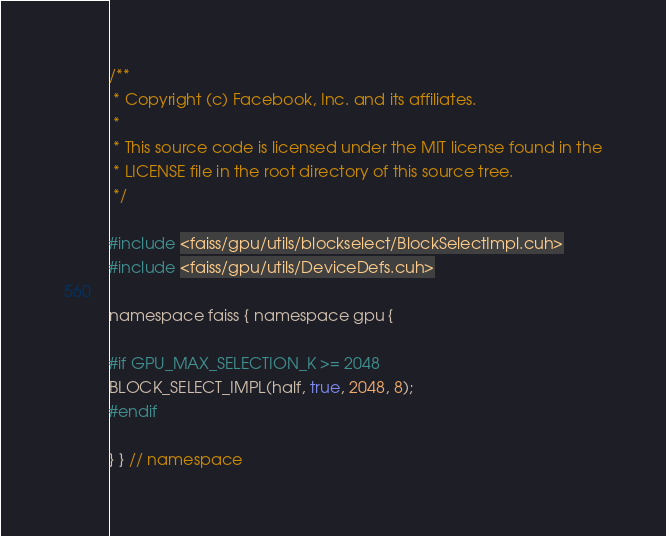Convert code to text. <code><loc_0><loc_0><loc_500><loc_500><_Cuda_>/**
 * Copyright (c) Facebook, Inc. and its affiliates.
 *
 * This source code is licensed under the MIT license found in the
 * LICENSE file in the root directory of this source tree.
 */

#include <faiss/gpu/utils/blockselect/BlockSelectImpl.cuh>
#include <faiss/gpu/utils/DeviceDefs.cuh>

namespace faiss { namespace gpu {

#if GPU_MAX_SELECTION_K >= 2048
BLOCK_SELECT_IMPL(half, true, 2048, 8);
#endif

} } // namespace
</code> 